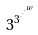Convert formula to latex. <formula><loc_0><loc_0><loc_500><loc_500>3 ^ { 3 ^ { \cdot ^ { \cdot ^ { \cdot ^ { w } } } } }</formula> 